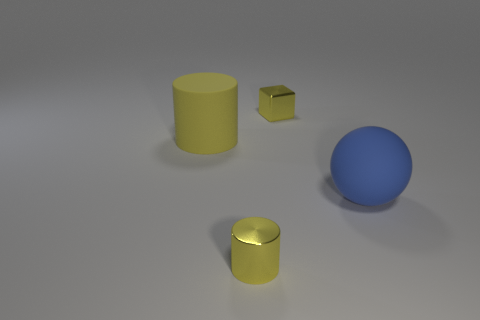Add 4 small cubes. How many objects exist? 8 Subtract all balls. How many objects are left? 3 Subtract all tiny matte spheres. Subtract all small objects. How many objects are left? 2 Add 4 tiny yellow cylinders. How many tiny yellow cylinders are left? 5 Add 3 small things. How many small things exist? 5 Subtract 1 yellow blocks. How many objects are left? 3 